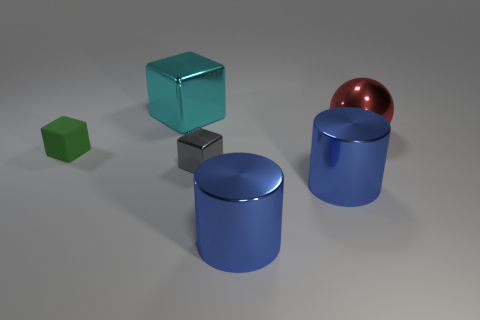Are there any gray objects to the left of the gray block?
Give a very brief answer. No. The red sphere that is the same material as the tiny gray object is what size?
Ensure brevity in your answer.  Large. What number of metallic cylinders have the same color as the large ball?
Your response must be concise. 0. Is the number of small metallic cubes that are behind the tiny metallic cube less than the number of blue objects that are left of the large cyan shiny object?
Keep it short and to the point. No. What is the size of the block in front of the tiny green rubber block?
Provide a succinct answer. Small. Are there any large objects that have the same material as the green cube?
Provide a short and direct response. No. Is the large cyan thing made of the same material as the gray block?
Offer a terse response. Yes. What is the color of the shiny sphere that is the same size as the cyan object?
Keep it short and to the point. Red. What number of other things are there of the same shape as the big red metal thing?
Your answer should be very brief. 0. There is a green rubber block; is its size the same as the metal block in front of the green cube?
Provide a short and direct response. Yes. 